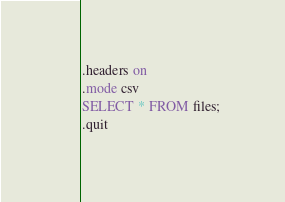<code> <loc_0><loc_0><loc_500><loc_500><_SQL_>.headers on
.mode csv
SELECT * FROM files;
.quit
</code> 